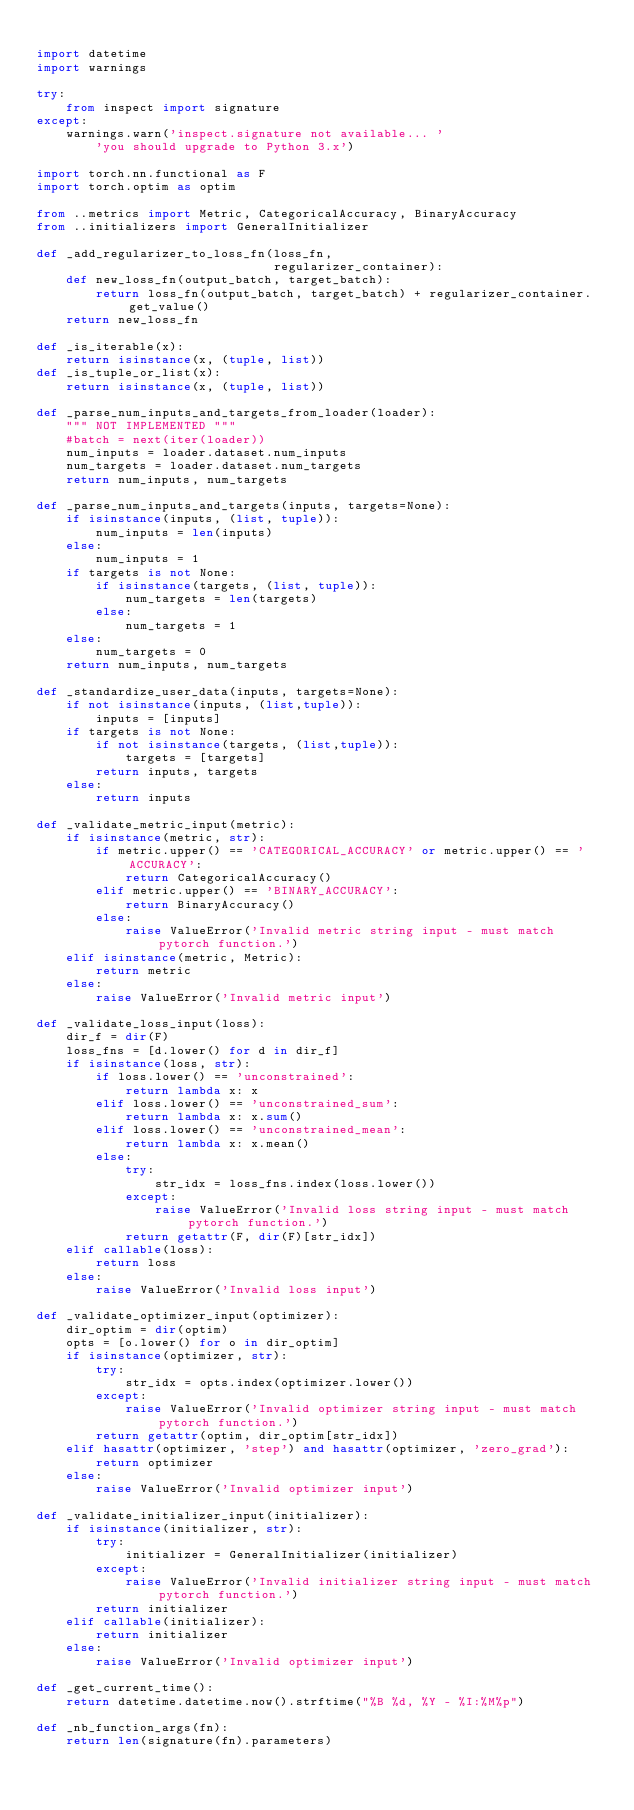<code> <loc_0><loc_0><loc_500><loc_500><_Python_>
import datetime
import warnings

try:
    from inspect import signature
except:
    warnings.warn('inspect.signature not available... '
        'you should upgrade to Python 3.x')

import torch.nn.functional as F
import torch.optim as optim

from ..metrics import Metric, CategoricalAccuracy, BinaryAccuracy
from ..initializers import GeneralInitializer

def _add_regularizer_to_loss_fn(loss_fn, 
                                regularizer_container):
    def new_loss_fn(output_batch, target_batch):
        return loss_fn(output_batch, target_batch) + regularizer_container.get_value()
    return new_loss_fn

def _is_iterable(x):
    return isinstance(x, (tuple, list))
def _is_tuple_or_list(x):
    return isinstance(x, (tuple, list))

def _parse_num_inputs_and_targets_from_loader(loader):
    """ NOT IMPLEMENTED """
    #batch = next(iter(loader))
    num_inputs = loader.dataset.num_inputs
    num_targets = loader.dataset.num_targets
    return num_inputs, num_targets

def _parse_num_inputs_and_targets(inputs, targets=None):
    if isinstance(inputs, (list, tuple)):
        num_inputs = len(inputs)
    else:
        num_inputs = 1
    if targets is not None:
        if isinstance(targets, (list, tuple)):
            num_targets = len(targets)
        else:
            num_targets = 1
    else:
        num_targets = 0
    return num_inputs, num_targets

def _standardize_user_data(inputs, targets=None):
    if not isinstance(inputs, (list,tuple)):
        inputs = [inputs]
    if targets is not None:
        if not isinstance(targets, (list,tuple)):
            targets = [targets]
        return inputs, targets
    else:
        return inputs

def _validate_metric_input(metric):
    if isinstance(metric, str):
        if metric.upper() == 'CATEGORICAL_ACCURACY' or metric.upper() == 'ACCURACY':
            return CategoricalAccuracy()
        elif metric.upper() == 'BINARY_ACCURACY':
            return BinaryAccuracy()
        else:
            raise ValueError('Invalid metric string input - must match pytorch function.')
    elif isinstance(metric, Metric):
        return metric
    else:
        raise ValueError('Invalid metric input')

def _validate_loss_input(loss):
    dir_f = dir(F)
    loss_fns = [d.lower() for d in dir_f]
    if isinstance(loss, str):
        if loss.lower() == 'unconstrained':
            return lambda x: x
        elif loss.lower() == 'unconstrained_sum':
            return lambda x: x.sum()
        elif loss.lower() == 'unconstrained_mean':
            return lambda x: x.mean()
        else:
            try:
                str_idx = loss_fns.index(loss.lower())
            except:
                raise ValueError('Invalid loss string input - must match pytorch function.')
            return getattr(F, dir(F)[str_idx])
    elif callable(loss):
        return loss
    else:
        raise ValueError('Invalid loss input')

def _validate_optimizer_input(optimizer):
    dir_optim = dir(optim)
    opts = [o.lower() for o in dir_optim]
    if isinstance(optimizer, str):
        try:
            str_idx = opts.index(optimizer.lower())    
        except:
            raise ValueError('Invalid optimizer string input - must match pytorch function.')
        return getattr(optim, dir_optim[str_idx])
    elif hasattr(optimizer, 'step') and hasattr(optimizer, 'zero_grad'):
        return optimizer
    else:
        raise ValueError('Invalid optimizer input')

def _validate_initializer_input(initializer):
    if isinstance(initializer, str):
        try:
            initializer = GeneralInitializer(initializer)
        except:
            raise ValueError('Invalid initializer string input - must match pytorch function.')
        return initializer
    elif callable(initializer):
        return initializer
    else:
        raise ValueError('Invalid optimizer input')

def _get_current_time():
    return datetime.datetime.now().strftime("%B %d, %Y - %I:%M%p")

def _nb_function_args(fn):
    return len(signature(fn).parameters)</code> 